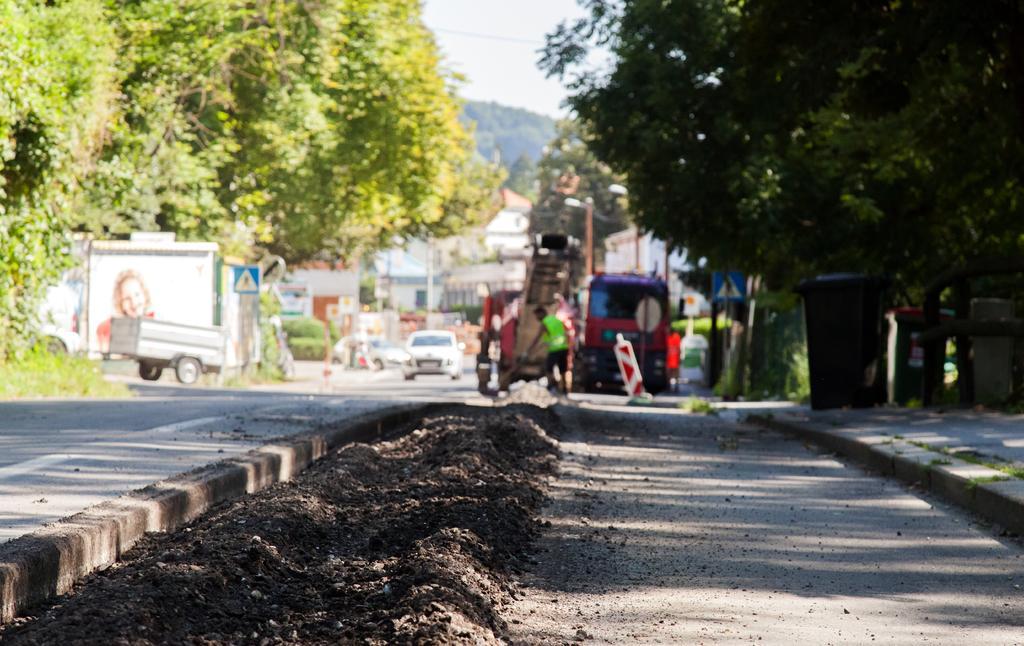Can you describe this image briefly? In this image I can see the road, few trees which are green in color, few vehicles, few persons, few poles, the sidewalk and a black colored object on the sidewalk. In the background I can see few buildings, a mountain and the sky. 